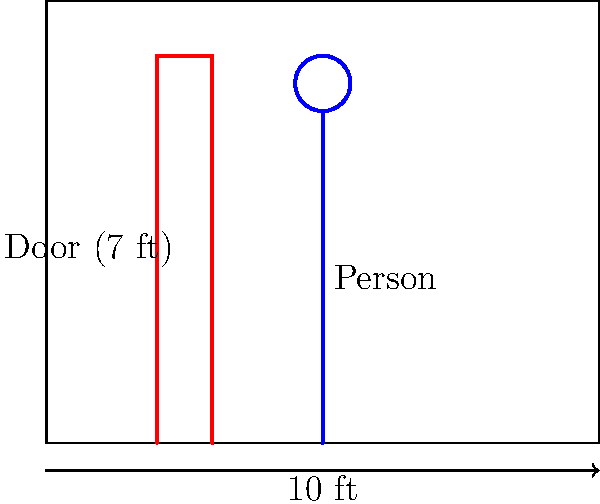In a surveillance photo, a person is standing next to a standard door known to be 7 feet tall. The photo frame represents 10 feet horizontally. If the person's height in the photo is 6 units and the door's height is 7 units, estimate the person's actual height in feet. To estimate the person's height, we'll use proportional reasoning:

1. Establish the known information:
   - Door height in reality: 7 feet
   - Door height in photo: 7 units
   - Person's height in photo: 6 units

2. Set up a proportion:
   $\frac{\text{Door height in reality}}{\text{Door height in photo}} = \frac{\text{Person's height in reality}}{\text{Person's height in photo}}$

3. Substitute the known values:
   $\frac{7 \text{ feet}}{7 \text{ units}} = \frac{x \text{ feet}}{6 \text{ units}}$

4. Cross multiply:
   $7 \cdot 6 = 7x$

5. Solve for x:
   $42 = 7x$
   $x = 42 \div 7 = 6$

Therefore, the person's estimated height is 6 feet.
Answer: 6 feet 